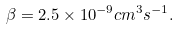<formula> <loc_0><loc_0><loc_500><loc_500>\beta = 2 . 5 \times 1 0 ^ { - 9 } c m ^ { 3 } s ^ { - 1 } .</formula> 